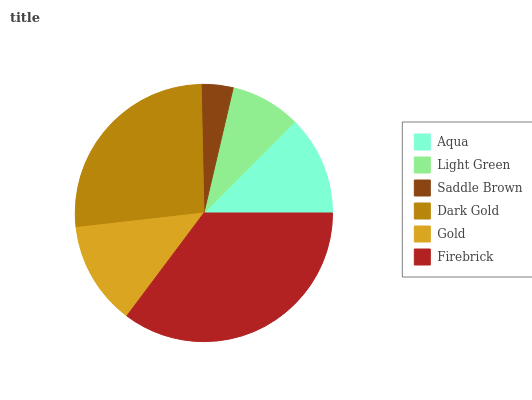Is Saddle Brown the minimum?
Answer yes or no. Yes. Is Firebrick the maximum?
Answer yes or no. Yes. Is Light Green the minimum?
Answer yes or no. No. Is Light Green the maximum?
Answer yes or no. No. Is Aqua greater than Light Green?
Answer yes or no. Yes. Is Light Green less than Aqua?
Answer yes or no. Yes. Is Light Green greater than Aqua?
Answer yes or no. No. Is Aqua less than Light Green?
Answer yes or no. No. Is Gold the high median?
Answer yes or no. Yes. Is Aqua the low median?
Answer yes or no. Yes. Is Saddle Brown the high median?
Answer yes or no. No. Is Firebrick the low median?
Answer yes or no. No. 